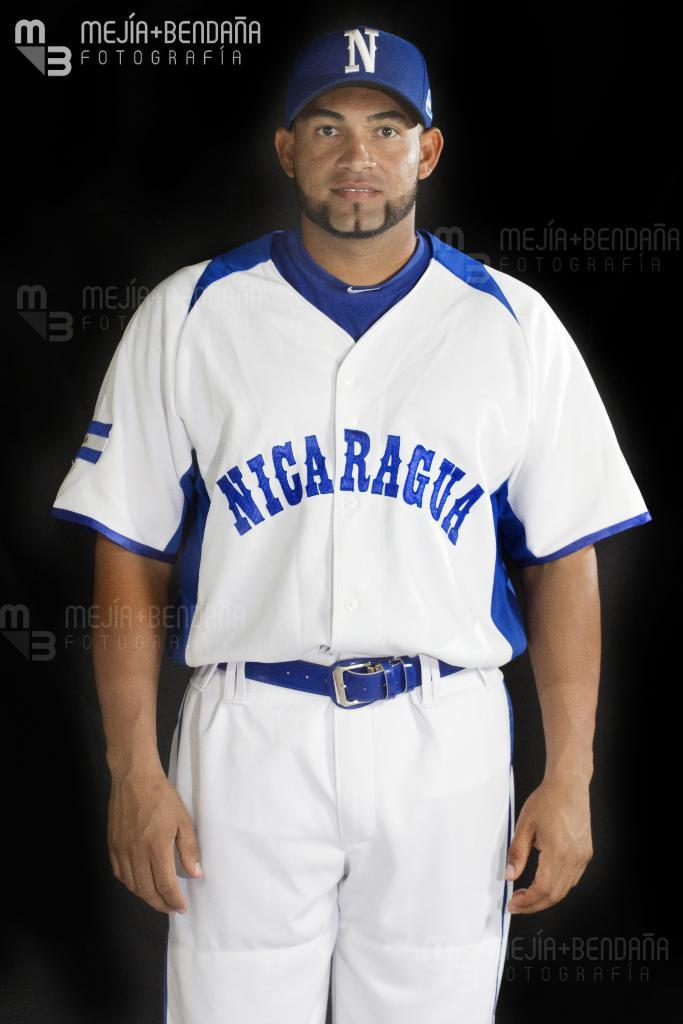<image>
Offer a succinct explanation of the picture presented. A man in a Nicarugua blue and white basesball uniform poses in this photo by Mejia + Bendana Fotografia. 